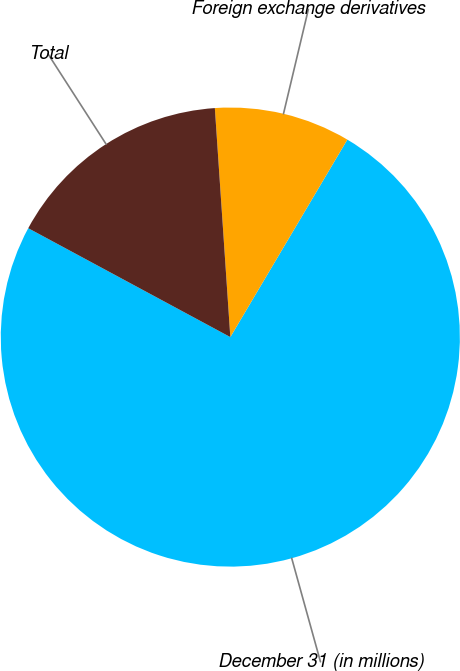<chart> <loc_0><loc_0><loc_500><loc_500><pie_chart><fcel>December 31 (in millions)<fcel>Foreign exchange derivatives<fcel>Total<nl><fcel>74.35%<fcel>9.59%<fcel>16.06%<nl></chart> 